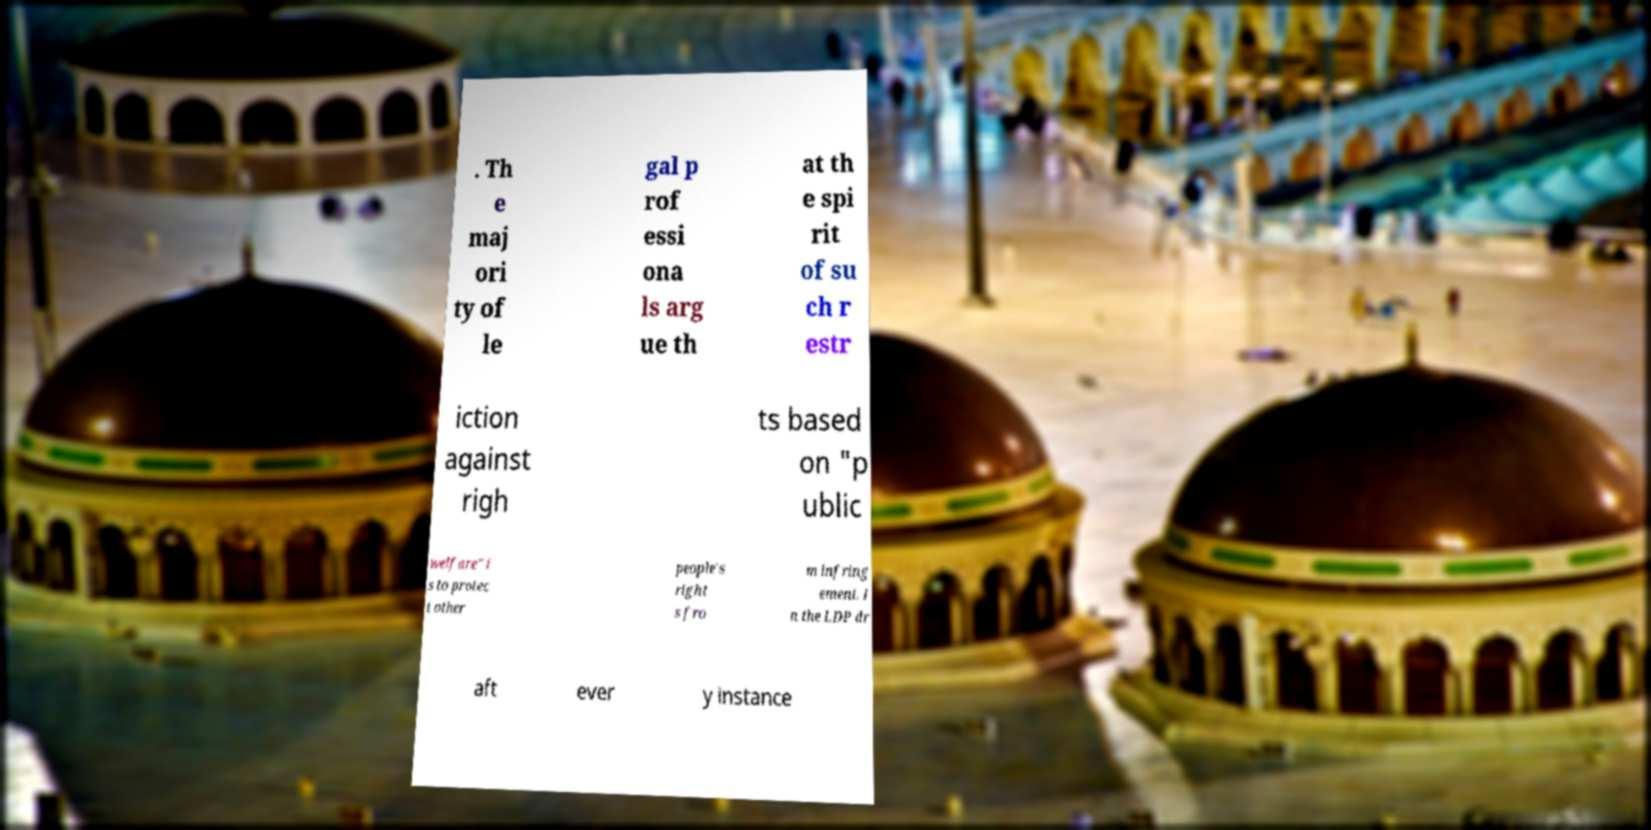Can you read and provide the text displayed in the image?This photo seems to have some interesting text. Can you extract and type it out for me? . Th e maj ori ty of le gal p rof essi ona ls arg ue th at th e spi rit of su ch r estr iction against righ ts based on "p ublic welfare" i s to protec t other people's right s fro m infring ement. I n the LDP dr aft ever y instance 